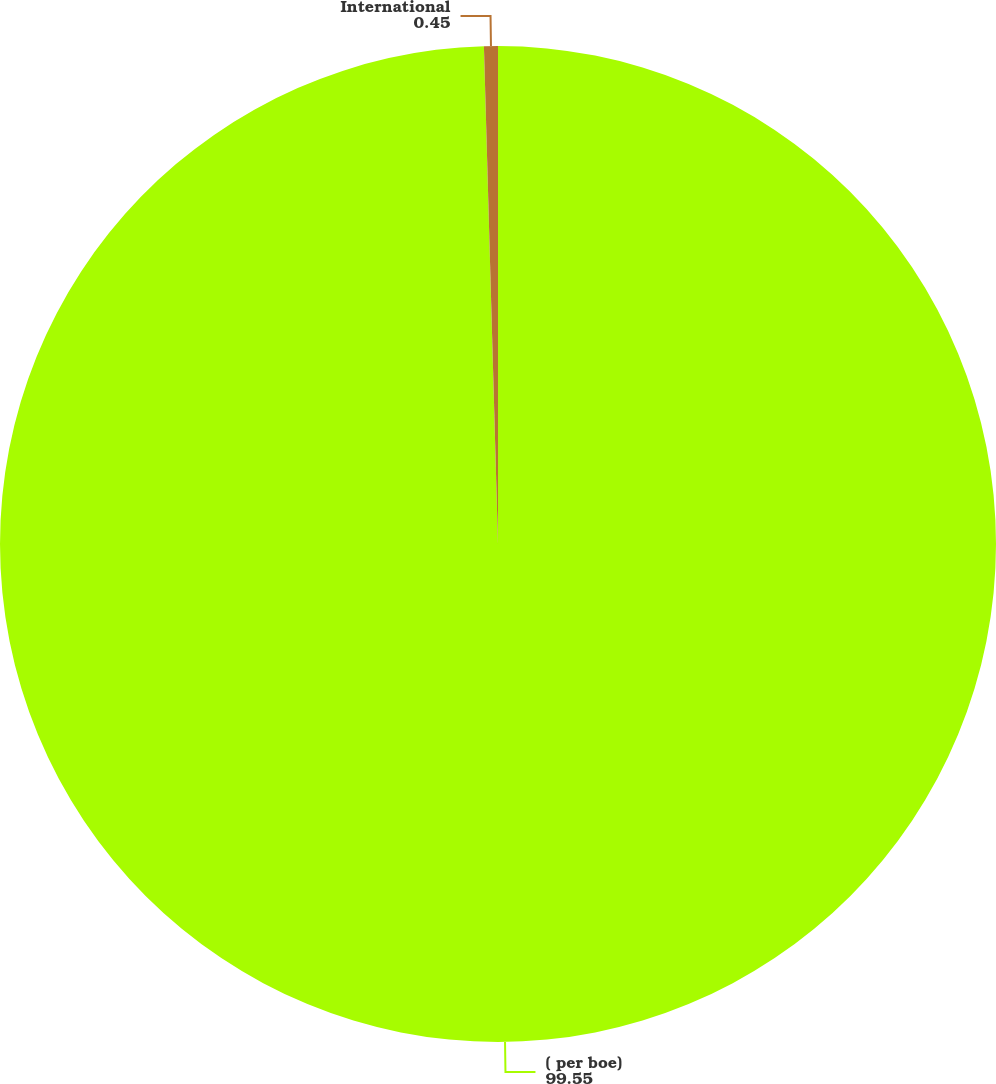Convert chart. <chart><loc_0><loc_0><loc_500><loc_500><pie_chart><fcel>( per boe)<fcel>International<nl><fcel>99.55%<fcel>0.45%<nl></chart> 